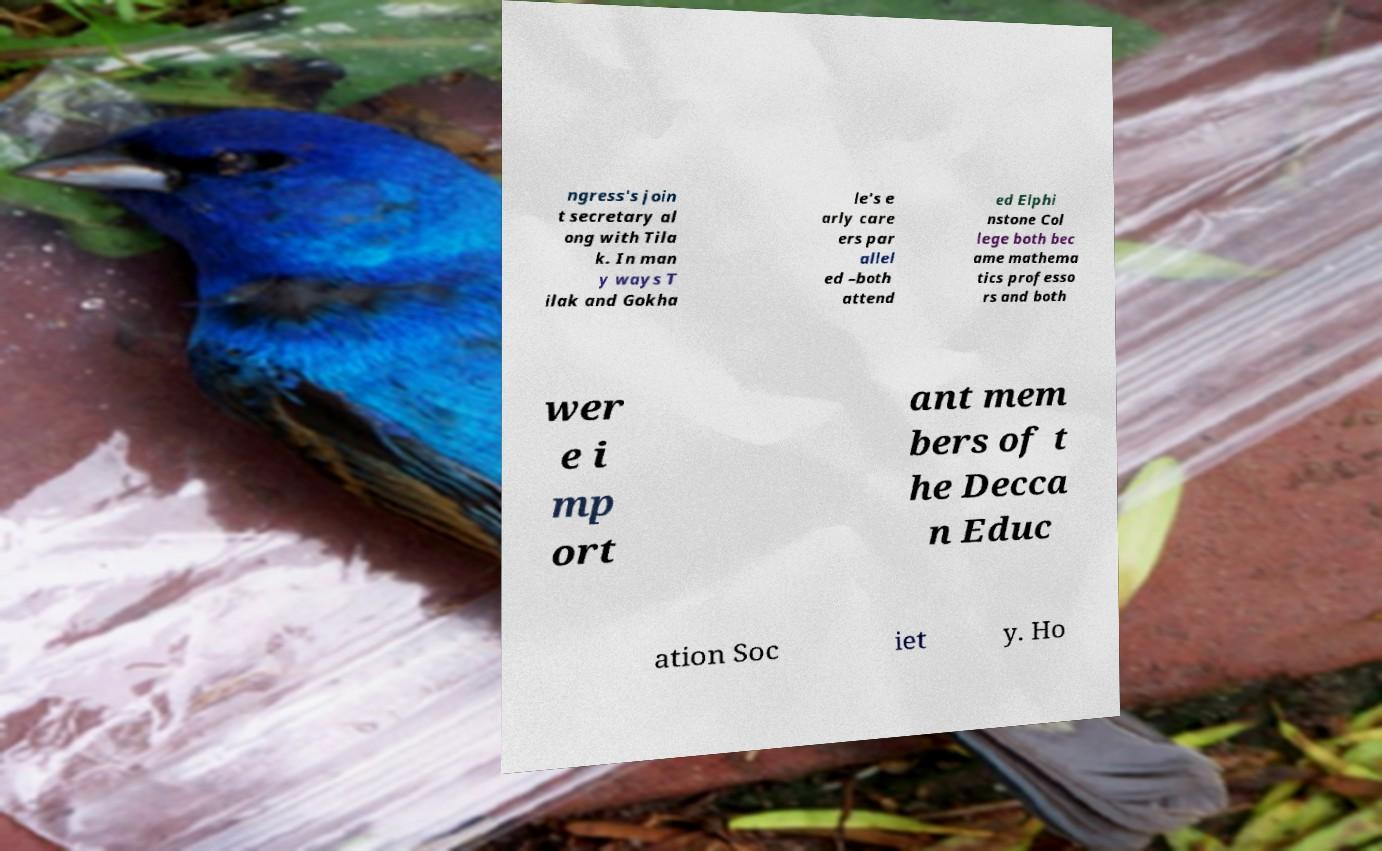Could you assist in decoding the text presented in this image and type it out clearly? ngress's join t secretary al ong with Tila k. In man y ways T ilak and Gokha le's e arly care ers par allel ed –both attend ed Elphi nstone Col lege both bec ame mathema tics professo rs and both wer e i mp ort ant mem bers of t he Decca n Educ ation Soc iet y. Ho 